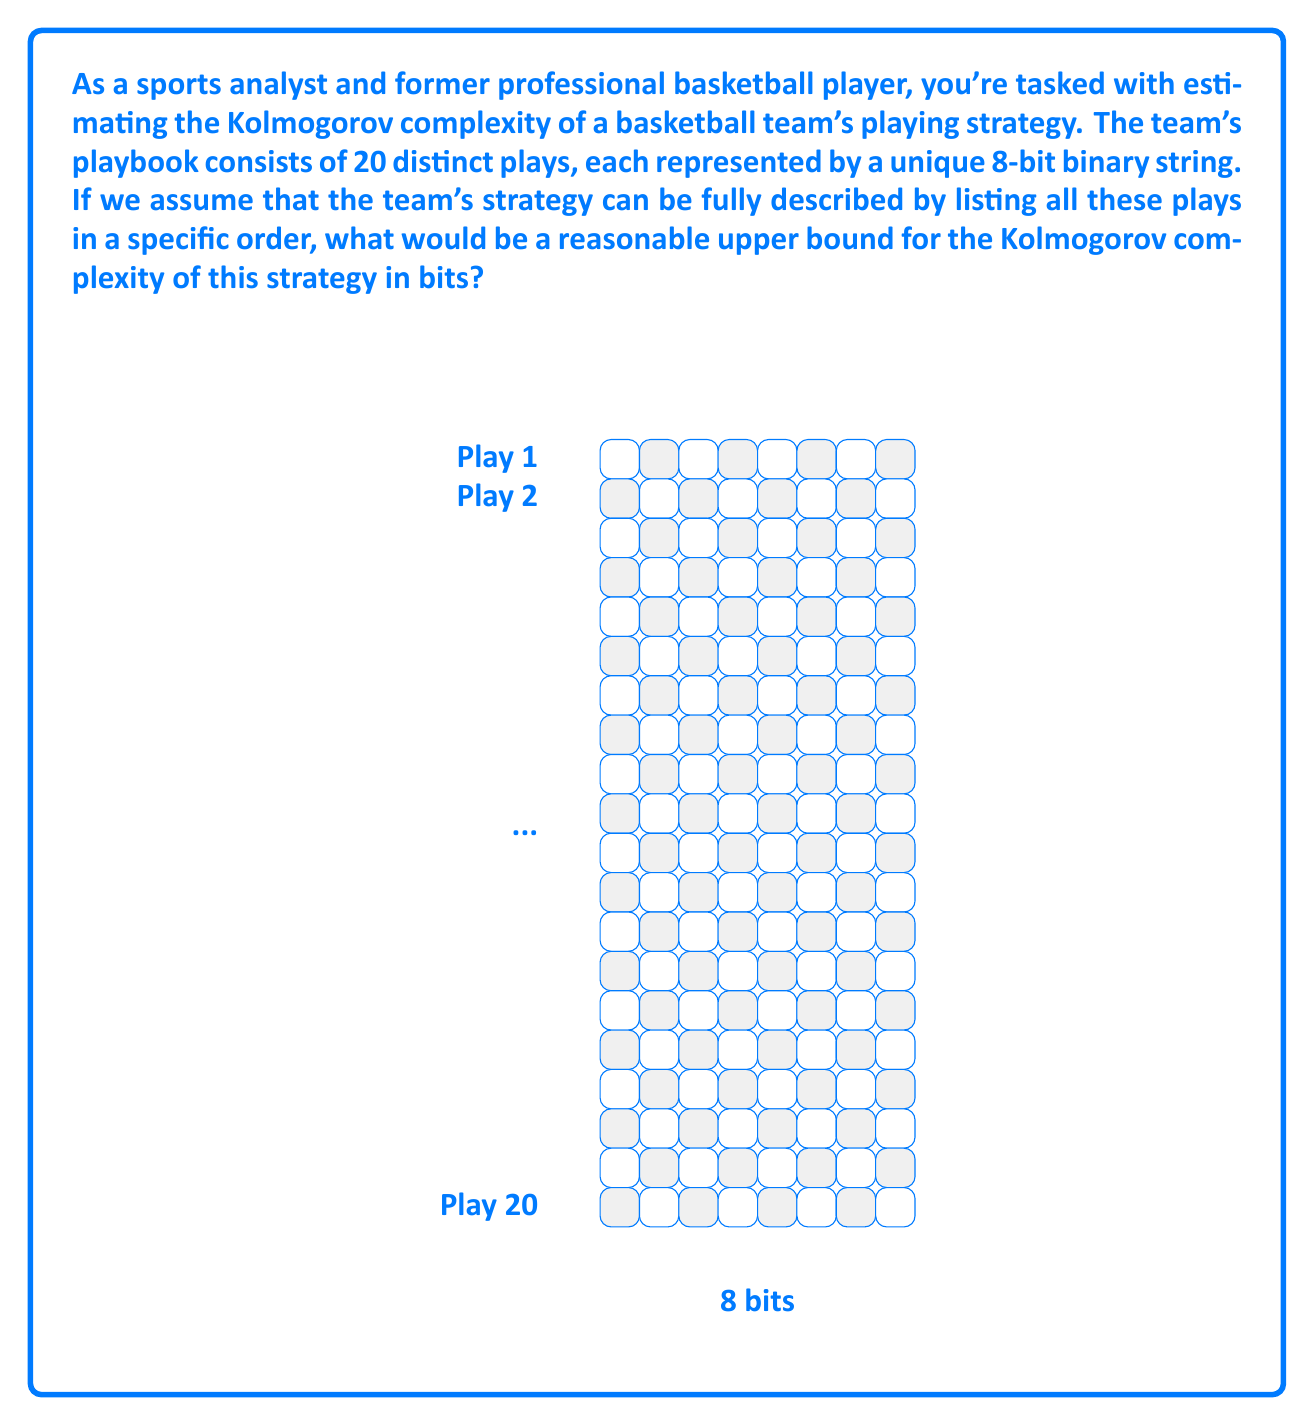Can you answer this question? To estimate the Kolmogorov complexity of the team's playing strategy, we need to consider the following steps:

1) Each play is represented by an 8-bit string. Therefore, the information content of each play is 8 bits.

2) There are 20 distinct plays in total.

3) The strategy is fully described by listing all these plays in a specific order.

4) To calculate an upper bound for the Kolmogorov complexity, we can consider the total information needed to represent all plays plus some overhead for the program that lists them:

   a) Information for all plays: $20 \times 8 = 160$ bits

   b) Overhead for the program: Let's estimate this generously as 40 bits. This could include instructions for reading and outputting the plays.

5) The total upper bound would then be:

   $$160 + 40 = 200 \text{ bits}$$

This is a reasonable upper bound because:

- It accounts for all the information in the plays themselves.
- It includes some overhead for the simple program to list the plays.
- In reality, there might be patterns or redundancies in the plays that could allow for further compression, but this upper bound doesn't assume any such optimizations.

It's worth noting that this is a simplified model. In practice, a team's strategy might involve more complex elements, but this estimate provides a basic framework for thinking about the Kolmogorov complexity of a playing strategy.
Answer: 200 bits 